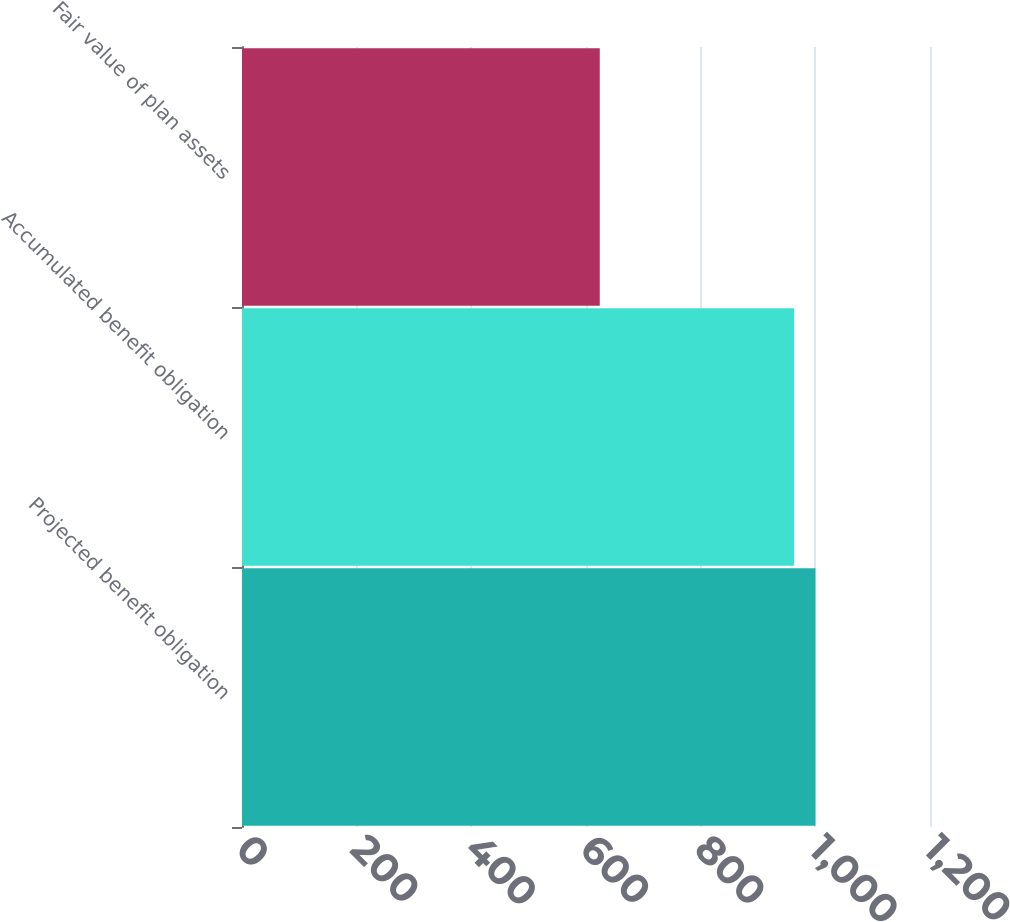Convert chart to OTSL. <chart><loc_0><loc_0><loc_500><loc_500><bar_chart><fcel>Projected benefit obligation<fcel>Accumulated benefit obligation<fcel>Fair value of plan assets<nl><fcel>1000.2<fcel>963<fcel>624<nl></chart> 